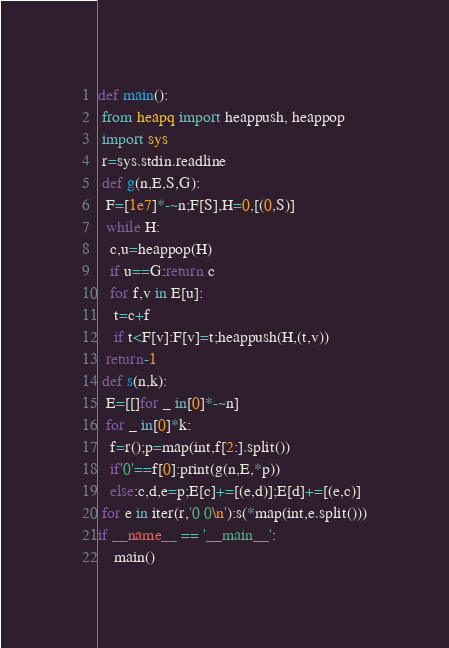Convert code to text. <code><loc_0><loc_0><loc_500><loc_500><_Python_>def main():
 from heapq import heappush, heappop
 import sys
 r=sys.stdin.readline
 def g(n,E,S,G):
  F=[1e7]*-~n;F[S],H=0,[(0,S)]
  while H:
   c,u=heappop(H)
   if u==G:return c
   for f,v in E[u]:
    t=c+f
    if t<F[v]:F[v]=t;heappush(H,(t,v))
  return-1
 def s(n,k):
  E=[[]for _ in[0]*-~n]
  for _ in[0]*k:
   f=r();p=map(int,f[2:].split())
   if'0'==f[0]:print(g(n,E,*p))
   else:c,d,e=p;E[c]+=[(e,d)];E[d]+=[(e,c)]
 for e in iter(r,'0 0\n'):s(*map(int,e.split()))
if __name__ == '__main__':
    main()
</code> 